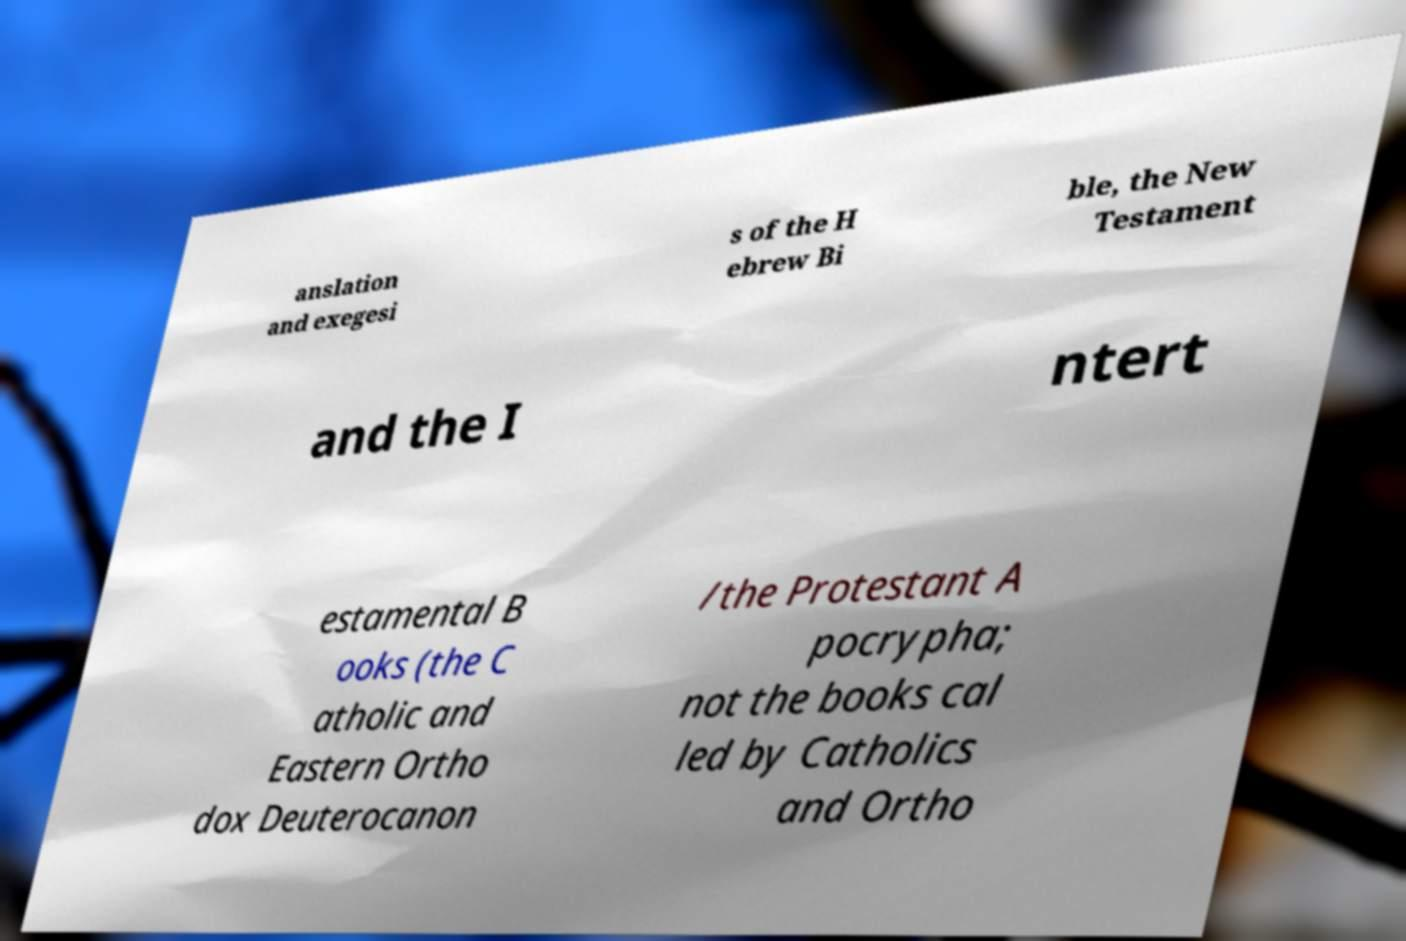For documentation purposes, I need the text within this image transcribed. Could you provide that? anslation and exegesi s of the H ebrew Bi ble, the New Testament and the I ntert estamental B ooks (the C atholic and Eastern Ortho dox Deuterocanon /the Protestant A pocrypha; not the books cal led by Catholics and Ortho 